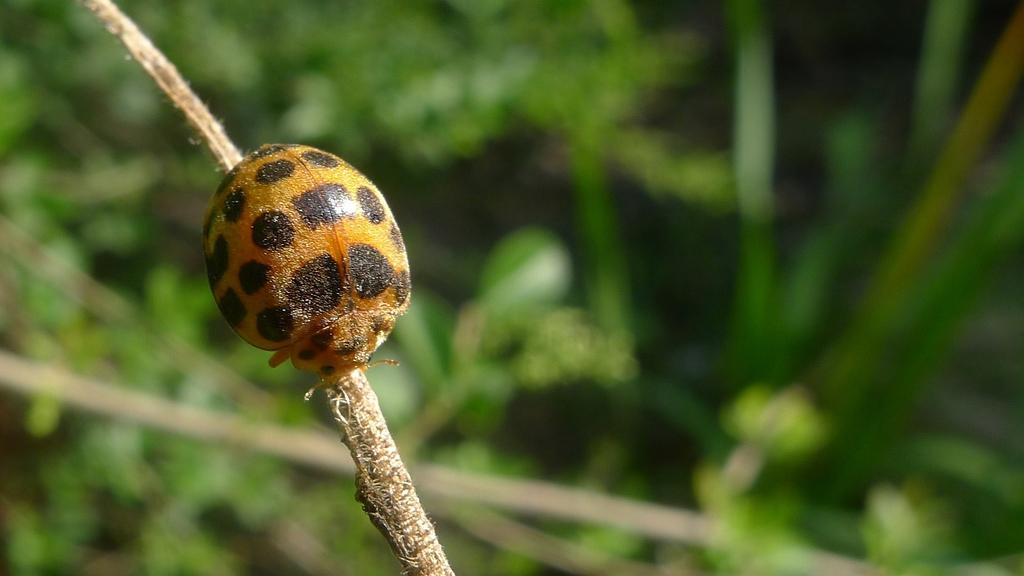What is present on the stem in the image? There is an insect on the stem in the image. What type of vegetation can be seen in the image? There are plants with leaves visible in the image. What type of government is depicted in the image? There is no depiction of a government in the image; it features an insect on a stem and plants with leaves. How many snails can be seen in the image? There are no snails present in the image. 